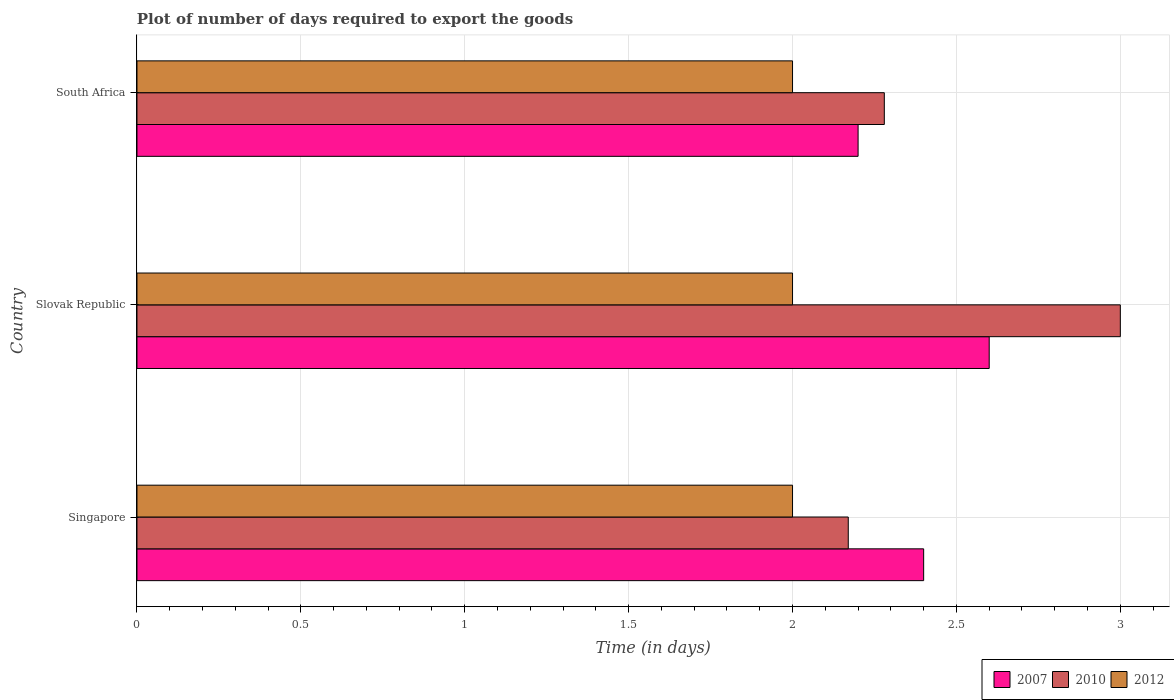How many groups of bars are there?
Give a very brief answer. 3. Are the number of bars on each tick of the Y-axis equal?
Provide a succinct answer. Yes. How many bars are there on the 2nd tick from the top?
Your response must be concise. 3. How many bars are there on the 2nd tick from the bottom?
Give a very brief answer. 3. What is the label of the 1st group of bars from the top?
Keep it short and to the point. South Africa. In how many cases, is the number of bars for a given country not equal to the number of legend labels?
Offer a terse response. 0. What is the time required to export goods in 2012 in Singapore?
Provide a short and direct response. 2. Across all countries, what is the minimum time required to export goods in 2010?
Provide a succinct answer. 2.17. In which country was the time required to export goods in 2012 maximum?
Offer a terse response. Singapore. In which country was the time required to export goods in 2010 minimum?
Give a very brief answer. Singapore. What is the difference between the time required to export goods in 2007 in Slovak Republic and that in South Africa?
Give a very brief answer. 0.4. What is the difference between the time required to export goods in 2012 in Slovak Republic and the time required to export goods in 2010 in South Africa?
Give a very brief answer. -0.28. What is the ratio of the time required to export goods in 2010 in Slovak Republic to that in South Africa?
Offer a terse response. 1.32. Is the time required to export goods in 2007 in Slovak Republic less than that in South Africa?
Make the answer very short. No. Is the difference between the time required to export goods in 2012 in Slovak Republic and South Africa greater than the difference between the time required to export goods in 2010 in Slovak Republic and South Africa?
Provide a short and direct response. No. What is the difference between the highest and the second highest time required to export goods in 2010?
Give a very brief answer. 0.72. What is the difference between the highest and the lowest time required to export goods in 2010?
Give a very brief answer. 0.83. Is it the case that in every country, the sum of the time required to export goods in 2012 and time required to export goods in 2007 is greater than the time required to export goods in 2010?
Your answer should be very brief. Yes. How many bars are there?
Your response must be concise. 9. Are all the bars in the graph horizontal?
Offer a very short reply. Yes. How many countries are there in the graph?
Ensure brevity in your answer.  3. What is the difference between two consecutive major ticks on the X-axis?
Keep it short and to the point. 0.5. Does the graph contain any zero values?
Offer a very short reply. No. Where does the legend appear in the graph?
Provide a short and direct response. Bottom right. What is the title of the graph?
Provide a short and direct response. Plot of number of days required to export the goods. Does "1996" appear as one of the legend labels in the graph?
Your answer should be compact. No. What is the label or title of the X-axis?
Offer a terse response. Time (in days). What is the Time (in days) in 2007 in Singapore?
Give a very brief answer. 2.4. What is the Time (in days) in 2010 in Singapore?
Offer a very short reply. 2.17. What is the Time (in days) in 2012 in Singapore?
Offer a terse response. 2. What is the Time (in days) in 2007 in Slovak Republic?
Offer a very short reply. 2.6. What is the Time (in days) of 2007 in South Africa?
Ensure brevity in your answer.  2.2. What is the Time (in days) of 2010 in South Africa?
Offer a very short reply. 2.28. Across all countries, what is the maximum Time (in days) of 2010?
Offer a terse response. 3. Across all countries, what is the minimum Time (in days) of 2010?
Your answer should be very brief. 2.17. What is the total Time (in days) of 2007 in the graph?
Offer a very short reply. 7.2. What is the total Time (in days) in 2010 in the graph?
Your answer should be very brief. 7.45. What is the difference between the Time (in days) in 2010 in Singapore and that in Slovak Republic?
Offer a terse response. -0.83. What is the difference between the Time (in days) in 2012 in Singapore and that in Slovak Republic?
Make the answer very short. 0. What is the difference between the Time (in days) in 2010 in Singapore and that in South Africa?
Your answer should be compact. -0.11. What is the difference between the Time (in days) of 2010 in Slovak Republic and that in South Africa?
Keep it short and to the point. 0.72. What is the difference between the Time (in days) in 2012 in Slovak Republic and that in South Africa?
Offer a very short reply. 0. What is the difference between the Time (in days) of 2007 in Singapore and the Time (in days) of 2010 in Slovak Republic?
Ensure brevity in your answer.  -0.6. What is the difference between the Time (in days) of 2010 in Singapore and the Time (in days) of 2012 in Slovak Republic?
Your answer should be compact. 0.17. What is the difference between the Time (in days) of 2007 in Singapore and the Time (in days) of 2010 in South Africa?
Make the answer very short. 0.12. What is the difference between the Time (in days) in 2007 in Singapore and the Time (in days) in 2012 in South Africa?
Give a very brief answer. 0.4. What is the difference between the Time (in days) of 2010 in Singapore and the Time (in days) of 2012 in South Africa?
Your answer should be very brief. 0.17. What is the difference between the Time (in days) of 2007 in Slovak Republic and the Time (in days) of 2010 in South Africa?
Offer a very short reply. 0.32. What is the difference between the Time (in days) in 2007 in Slovak Republic and the Time (in days) in 2012 in South Africa?
Ensure brevity in your answer.  0.6. What is the average Time (in days) of 2010 per country?
Offer a terse response. 2.48. What is the average Time (in days) of 2012 per country?
Provide a succinct answer. 2. What is the difference between the Time (in days) of 2007 and Time (in days) of 2010 in Singapore?
Your answer should be very brief. 0.23. What is the difference between the Time (in days) of 2010 and Time (in days) of 2012 in Singapore?
Give a very brief answer. 0.17. What is the difference between the Time (in days) in 2007 and Time (in days) in 2012 in Slovak Republic?
Offer a very short reply. 0.6. What is the difference between the Time (in days) of 2010 and Time (in days) of 2012 in Slovak Republic?
Provide a short and direct response. 1. What is the difference between the Time (in days) in 2007 and Time (in days) in 2010 in South Africa?
Your answer should be compact. -0.08. What is the difference between the Time (in days) of 2007 and Time (in days) of 2012 in South Africa?
Offer a very short reply. 0.2. What is the difference between the Time (in days) of 2010 and Time (in days) of 2012 in South Africa?
Your response must be concise. 0.28. What is the ratio of the Time (in days) of 2010 in Singapore to that in Slovak Republic?
Offer a very short reply. 0.72. What is the ratio of the Time (in days) of 2007 in Singapore to that in South Africa?
Provide a short and direct response. 1.09. What is the ratio of the Time (in days) of 2010 in Singapore to that in South Africa?
Your answer should be compact. 0.95. What is the ratio of the Time (in days) of 2012 in Singapore to that in South Africa?
Your response must be concise. 1. What is the ratio of the Time (in days) of 2007 in Slovak Republic to that in South Africa?
Provide a succinct answer. 1.18. What is the ratio of the Time (in days) in 2010 in Slovak Republic to that in South Africa?
Provide a short and direct response. 1.32. What is the difference between the highest and the second highest Time (in days) of 2010?
Offer a very short reply. 0.72. What is the difference between the highest and the lowest Time (in days) of 2010?
Offer a terse response. 0.83. 